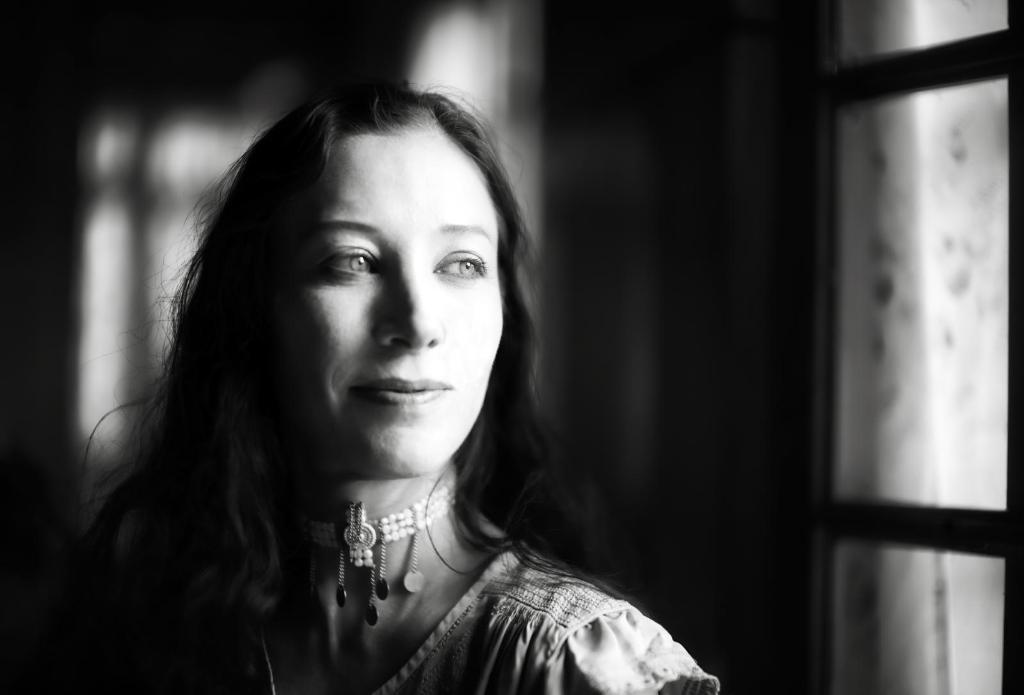Who is in the image? There is a woman in the image. What expression does the woman have? The woman is smiling. Can you describe the background of the image? The background of the image is blurry. What is the color scheme of the image? The image is black and white. What type of flowers can be seen in the woman's pail in the image? There are no flowers or pail present in the image. Is the woman celebrating her birthday in the image? There is no indication in the image that the woman is celebrating her birthday. 